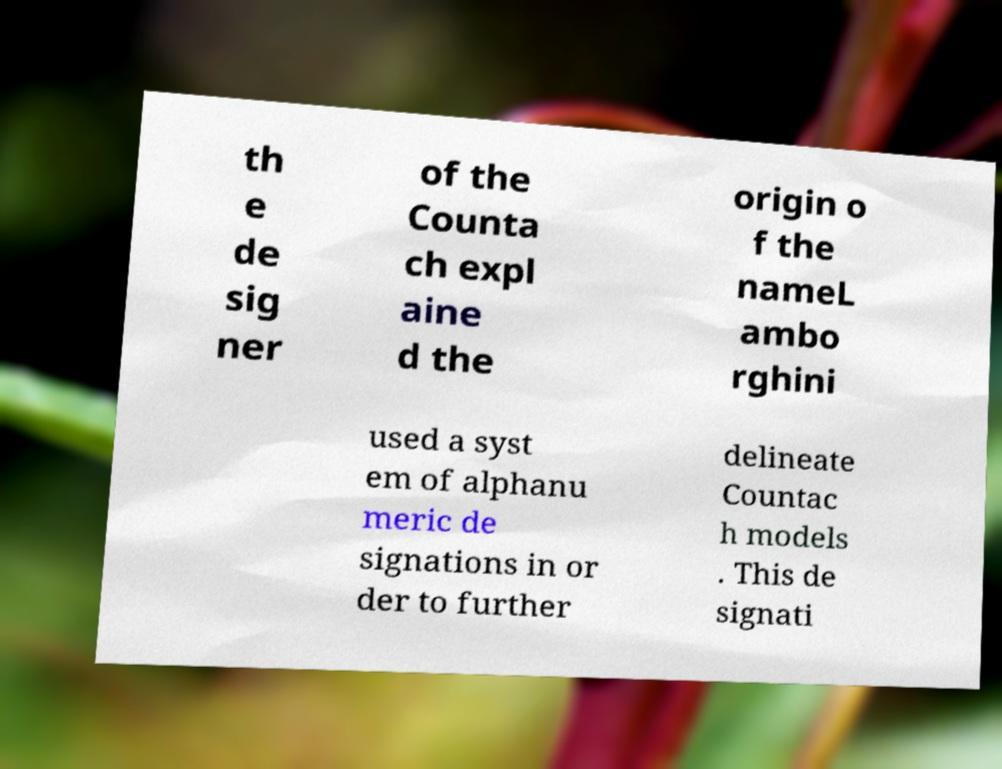Please read and relay the text visible in this image. What does it say? th e de sig ner of the Counta ch expl aine d the origin o f the nameL ambo rghini used a syst em of alphanu meric de signations in or der to further delineate Countac h models . This de signati 